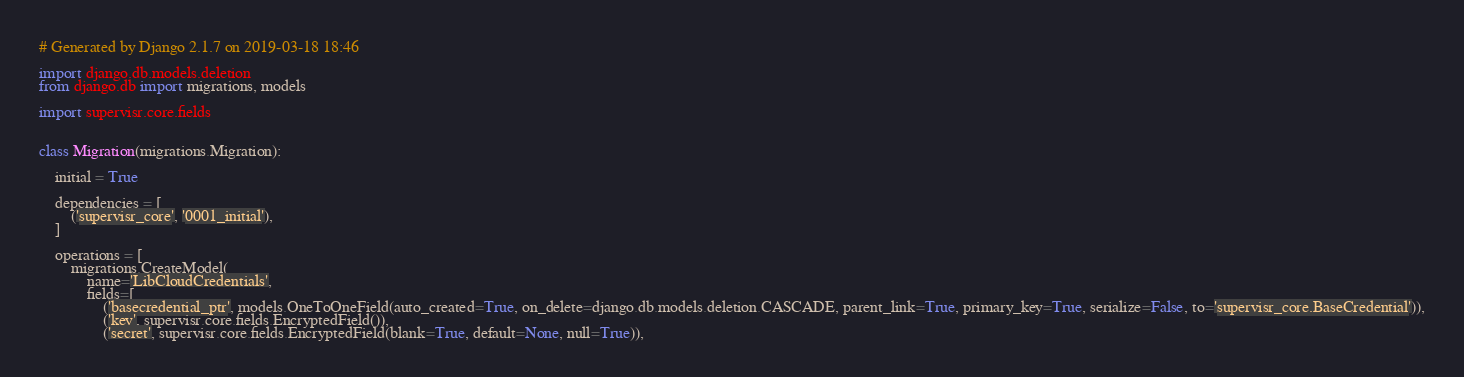<code> <loc_0><loc_0><loc_500><loc_500><_Python_># Generated by Django 2.1.7 on 2019-03-18 18:46

import django.db.models.deletion
from django.db import migrations, models

import supervisr.core.fields


class Migration(migrations.Migration):

    initial = True

    dependencies = [
        ('supervisr_core', '0001_initial'),
    ]

    operations = [
        migrations.CreateModel(
            name='LibCloudCredentials',
            fields=[
                ('basecredential_ptr', models.OneToOneField(auto_created=True, on_delete=django.db.models.deletion.CASCADE, parent_link=True, primary_key=True, serialize=False, to='supervisr_core.BaseCredential')),
                ('key', supervisr.core.fields.EncryptedField()),
                ('secret', supervisr.core.fields.EncryptedField(blank=True, default=None, null=True)),</code> 